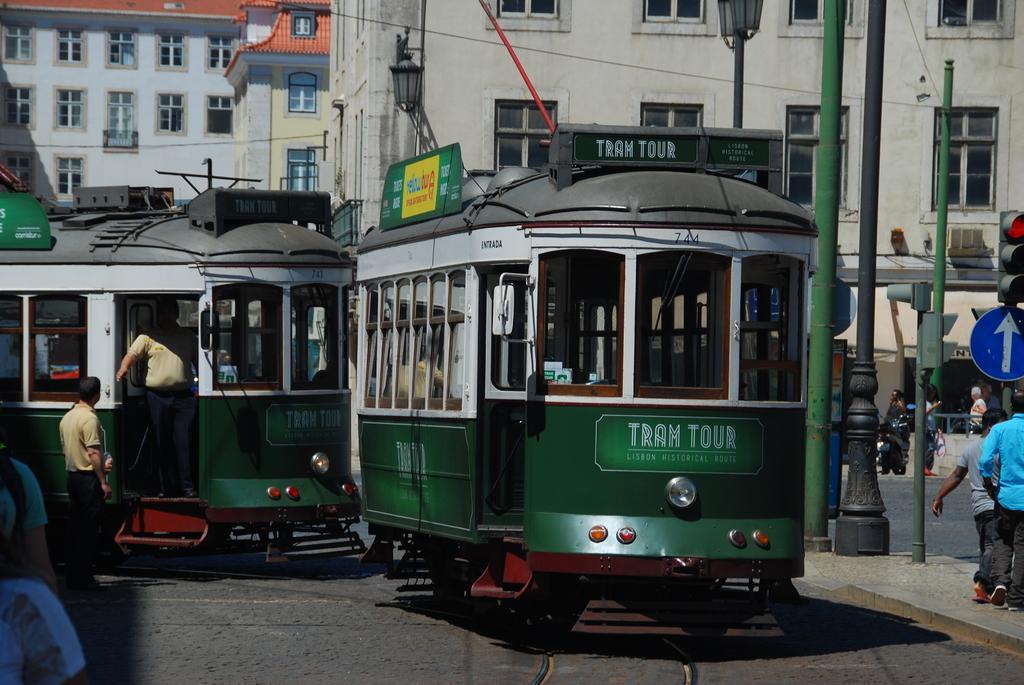Describe this image in one or two sentences. In this image there is a train , group of people, signal lights and a signboard attached to the pole, and in the background there are buildings. 